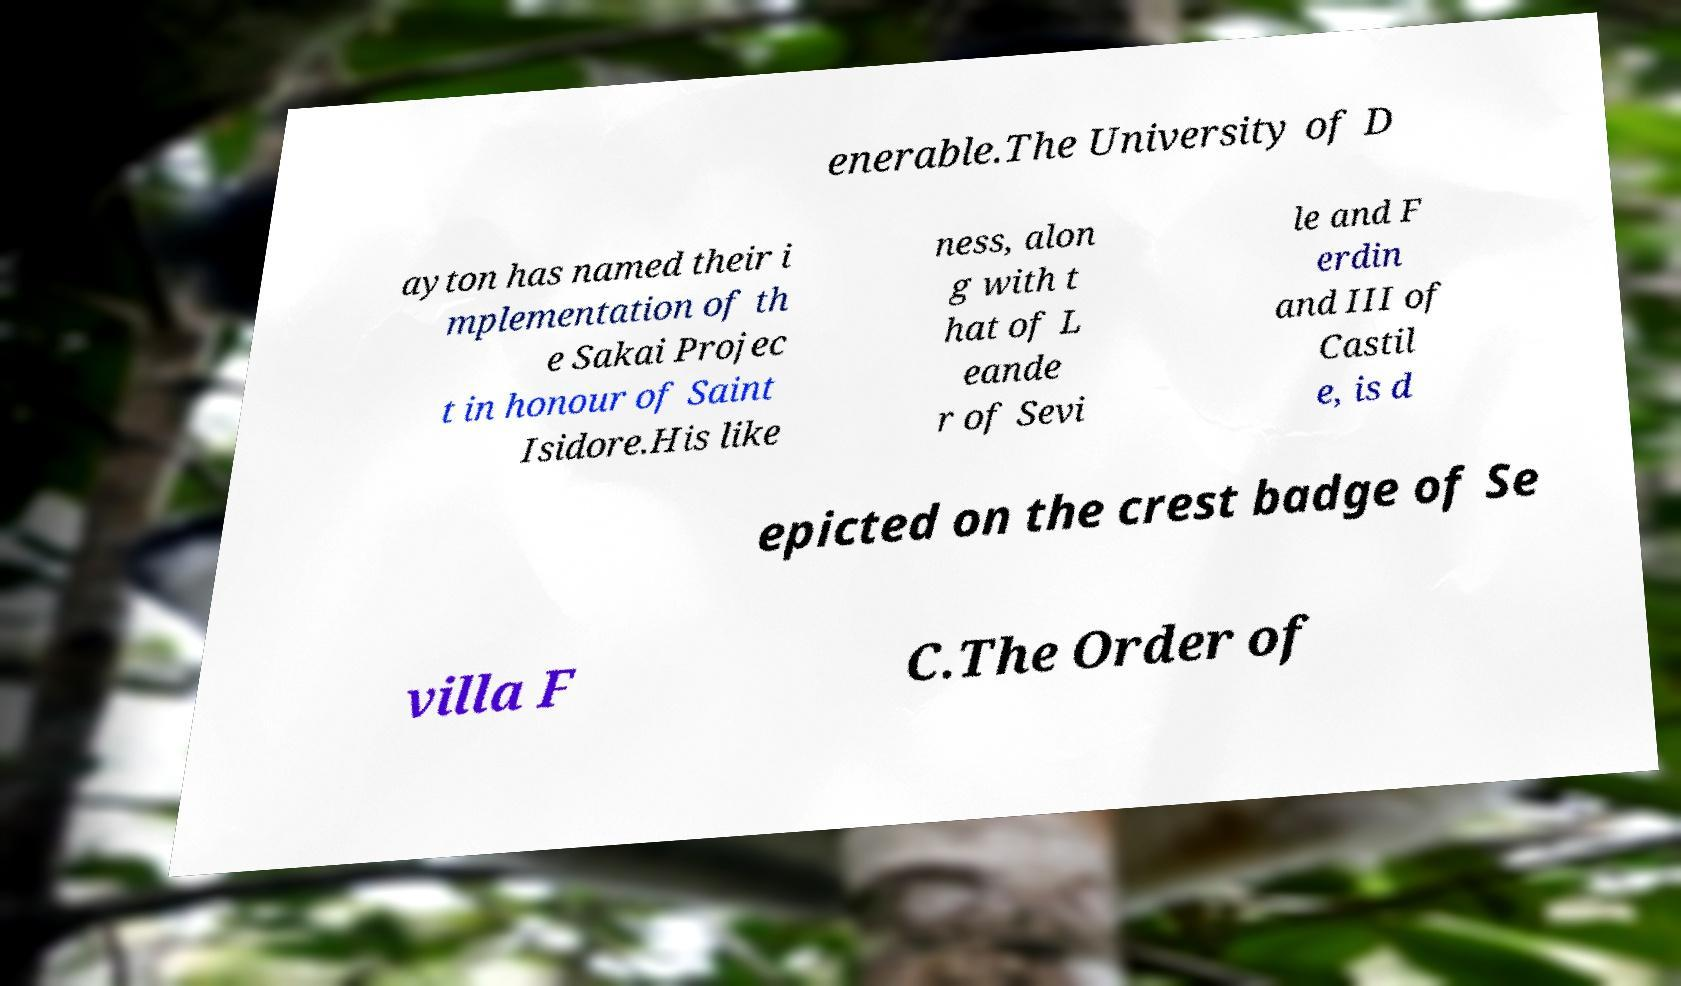What messages or text are displayed in this image? I need them in a readable, typed format. enerable.The University of D ayton has named their i mplementation of th e Sakai Projec t in honour of Saint Isidore.His like ness, alon g with t hat of L eande r of Sevi le and F erdin and III of Castil e, is d epicted on the crest badge of Se villa F C.The Order of 